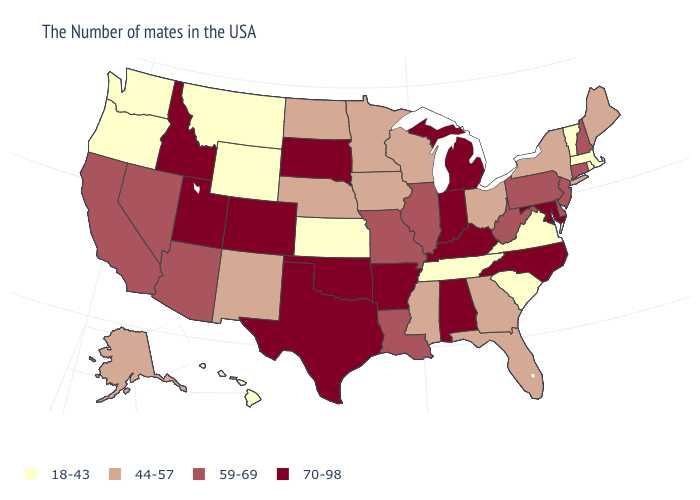Among the states that border New York , does Massachusetts have the lowest value?
Answer briefly. Yes. What is the highest value in states that border Kentucky?
Short answer required. 70-98. Which states have the highest value in the USA?
Give a very brief answer. Maryland, North Carolina, Michigan, Kentucky, Indiana, Alabama, Arkansas, Oklahoma, Texas, South Dakota, Colorado, Utah, Idaho. How many symbols are there in the legend?
Give a very brief answer. 4. What is the lowest value in the USA?
Give a very brief answer. 18-43. Does South Carolina have the lowest value in the South?
Short answer required. Yes. Name the states that have a value in the range 70-98?
Write a very short answer. Maryland, North Carolina, Michigan, Kentucky, Indiana, Alabama, Arkansas, Oklahoma, Texas, South Dakota, Colorado, Utah, Idaho. Among the states that border Maryland , does Virginia have the lowest value?
Concise answer only. Yes. Does Rhode Island have the lowest value in the Northeast?
Keep it brief. Yes. What is the value of Kentucky?
Short answer required. 70-98. What is the value of Louisiana?
Concise answer only. 59-69. Which states have the lowest value in the West?
Short answer required. Wyoming, Montana, Washington, Oregon, Hawaii. What is the highest value in the Northeast ?
Be succinct. 59-69. Which states have the lowest value in the USA?
Keep it brief. Massachusetts, Rhode Island, Vermont, Virginia, South Carolina, Tennessee, Kansas, Wyoming, Montana, Washington, Oregon, Hawaii. What is the value of Oregon?
Write a very short answer. 18-43. 